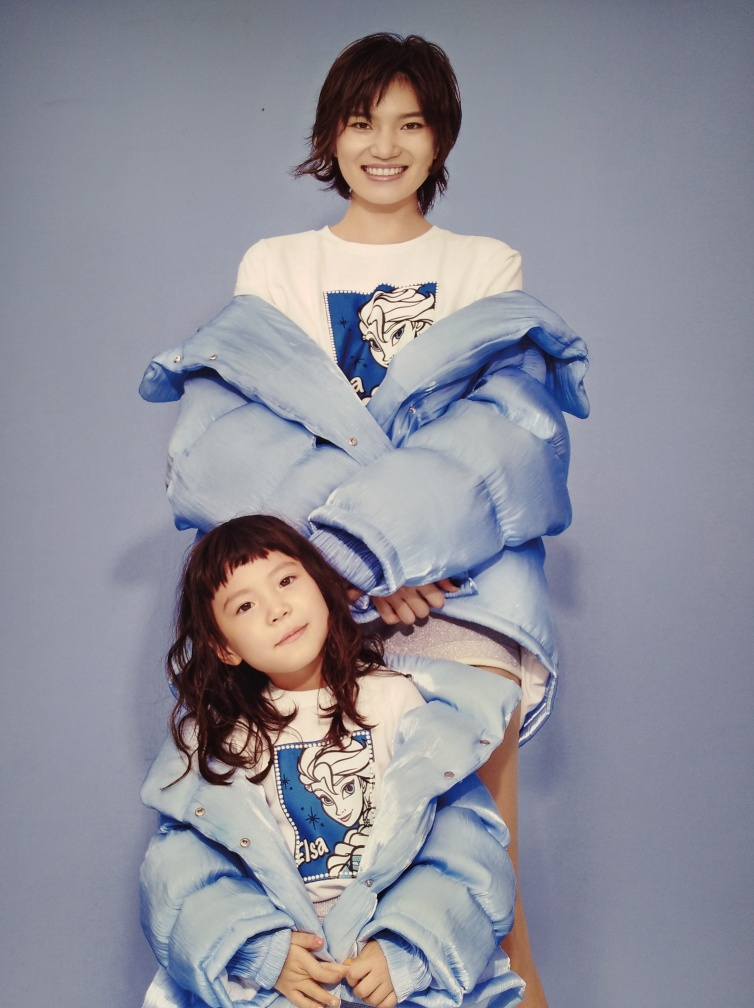Is the exposure of the image correct? The exposure of the photograph appears to be well-balanced, providing clarity and adequate illumination to the subjects without any areas being overly bright or unduly shadowed. 